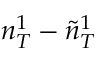Convert formula to latex. <formula><loc_0><loc_0><loc_500><loc_500>n _ { T } ^ { 1 } - \tilde { n } _ { T } ^ { 1 }</formula> 